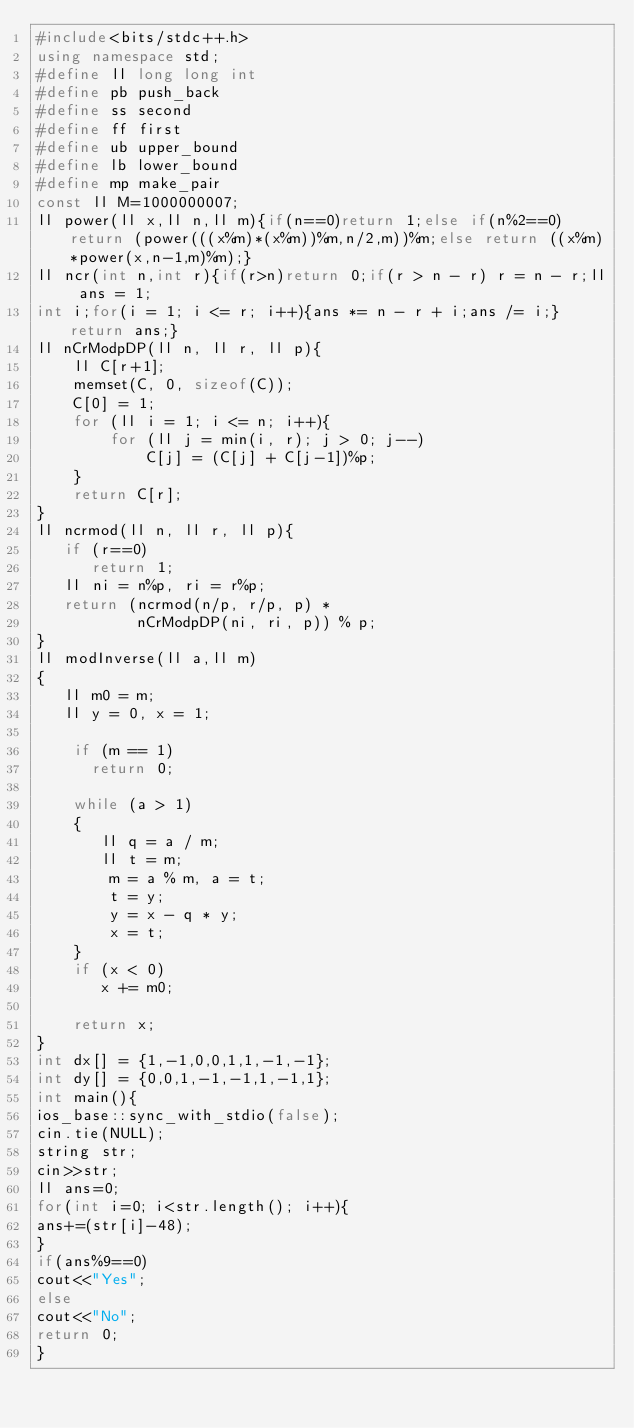Convert code to text. <code><loc_0><loc_0><loc_500><loc_500><_C++_>#include<bits/stdc++.h>
using namespace std;
#define ll long long int 
#define pb push_back
#define ss second
#define ff first 
#define ub upper_bound
#define lb lower_bound
#define mp make_pair
const ll M=1000000007;
ll power(ll x,ll n,ll m){if(n==0)return 1;else if(n%2==0)return (power(((x%m)*(x%m))%m,n/2,m))%m;else return ((x%m)*power(x,n-1,m)%m);}
ll ncr(int n,int r){if(r>n)return 0;if(r > n - r) r = n - r;ll ans = 1;
int i;for(i = 1; i <= r; i++){ans *= n - r + i;ans /= i;}return ans;}
ll nCrModpDP(ll n, ll r, ll p){ 
    ll C[r+1]; 
    memset(C, 0, sizeof(C)); 
    C[0] = 1;
    for (ll i = 1; i <= n; i++){ 
        for (ll j = min(i, r); j > 0; j--) 
            C[j] = (C[j] + C[j-1])%p; 
    } 
    return C[r]; 
} 
ll ncrmod(ll n, ll r, ll p){ 
   if (r==0) 
      return 1; 
   ll ni = n%p, ri = r%p; 
   return (ncrmod(n/p, r/p, p) * 
           nCrModpDP(ni, ri, p)) % p;  
} 
ll modInverse(ll a,ll m) 
{ 
   ll m0 = m; 
   ll y = 0, x = 1; 
  
    if (m == 1) 
      return 0; 
  
    while (a > 1) 
    { 
       ll q = a / m; 
       ll t = m; 
        m = a % m, a = t; 
        t = y; 
        y = x - q * y; 
        x = t; 
    } 
    if (x < 0) 
       x += m0; 
  
    return x; 
} 
int dx[] = {1,-1,0,0,1,1,-1,-1}; 
int dy[] = {0,0,1,-1,-1,1,-1,1}; 
int main(){
ios_base::sync_with_stdio(false);
cin.tie(NULL);
string str;
cin>>str;
ll ans=0;
for(int i=0; i<str.length(); i++){
ans+=(str[i]-48);
}
if(ans%9==0)
cout<<"Yes";
else
cout<<"No";
return 0;
}</code> 